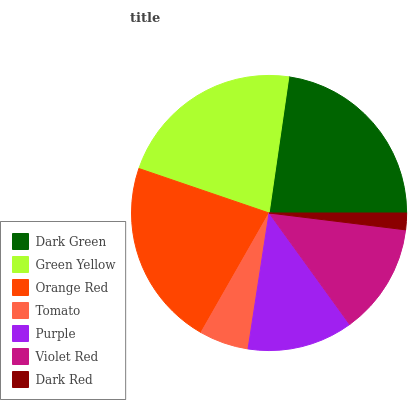Is Dark Red the minimum?
Answer yes or no. Yes. Is Dark Green the maximum?
Answer yes or no. Yes. Is Green Yellow the minimum?
Answer yes or no. No. Is Green Yellow the maximum?
Answer yes or no. No. Is Dark Green greater than Green Yellow?
Answer yes or no. Yes. Is Green Yellow less than Dark Green?
Answer yes or no. Yes. Is Green Yellow greater than Dark Green?
Answer yes or no. No. Is Dark Green less than Green Yellow?
Answer yes or no. No. Is Violet Red the high median?
Answer yes or no. Yes. Is Violet Red the low median?
Answer yes or no. Yes. Is Purple the high median?
Answer yes or no. No. Is Dark Green the low median?
Answer yes or no. No. 